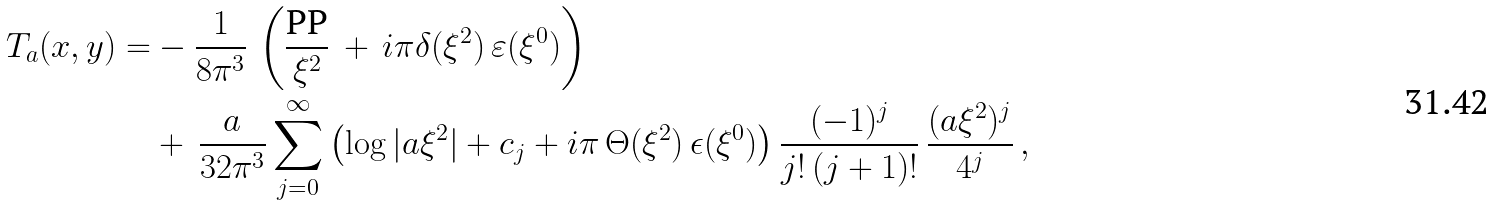<formula> <loc_0><loc_0><loc_500><loc_500>T _ { a } ( x , y ) = & - \frac { 1 } { 8 \pi ^ { 3 } } \, \left ( \frac { \text {PP} } { \xi ^ { 2 } } \, + \, i \pi \delta ( \xi ^ { 2 } ) \, \varepsilon ( \xi ^ { 0 } ) \right ) \\ & + \, \frac { a } { 3 2 \pi ^ { 3 } } \sum _ { j = 0 } ^ { \infty } \left ( \log | a \xi ^ { 2 } | + c _ { j } + i \pi \, \Theta ( \xi ^ { 2 } ) \, \epsilon ( \xi ^ { 0 } ) \right ) \frac { ( - 1 ) ^ { j } } { j ! \, ( j + 1 ) ! } \, \frac { ( a \xi ^ { 2 } ) ^ { j } } { 4 ^ { j } } \, ,</formula> 